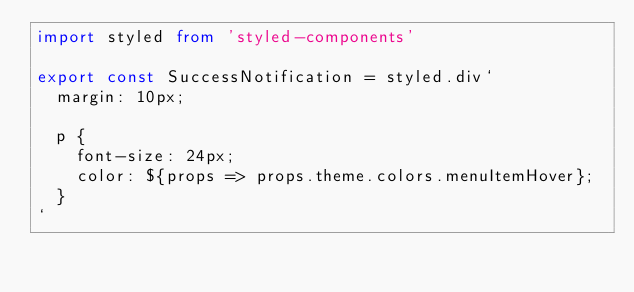<code> <loc_0><loc_0><loc_500><loc_500><_TypeScript_>import styled from 'styled-components'

export const SuccessNotification = styled.div`
  margin: 10px;

  p {
    font-size: 24px;
    color: ${props => props.theme.colors.menuItemHover};
  }
`</code> 